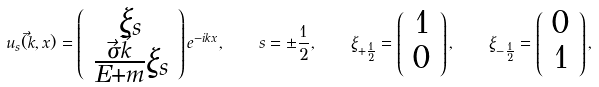Convert formula to latex. <formula><loc_0><loc_0><loc_500><loc_500>u _ { s } ( \vec { k } , x ) = \left ( \begin{array} { c } \xi _ { s } \\ \frac { \vec { \sigma } \vec { k } } { E + m } \xi _ { s } \end{array} \right ) e ^ { - i k x } , \quad s = \pm \frac { 1 } { 2 } , \quad \xi _ { + \frac { 1 } { 2 } } = \left ( \begin{array} { c } 1 \\ 0 \end{array} \right ) , \quad \xi _ { - \frac { 1 } { 2 } } = \left ( \begin{array} { c } 0 \\ 1 \end{array} \right ) ,</formula> 